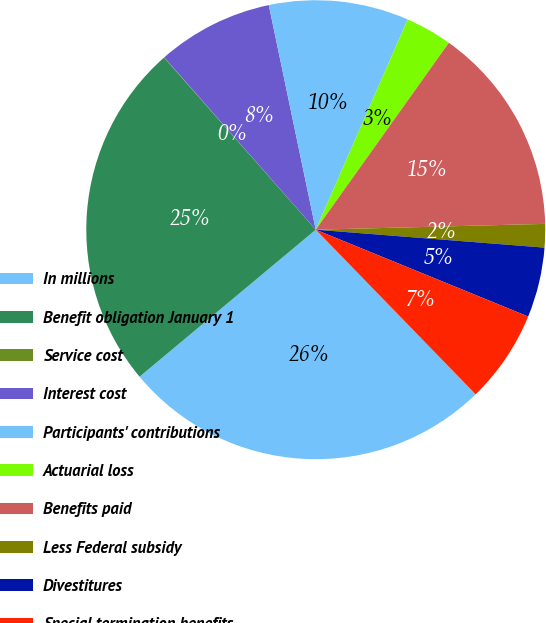Convert chart to OTSL. <chart><loc_0><loc_0><loc_500><loc_500><pie_chart><fcel>In millions<fcel>Benefit obligation January 1<fcel>Service cost<fcel>Interest cost<fcel>Participants' contributions<fcel>Actuarial loss<fcel>Benefits paid<fcel>Less Federal subsidy<fcel>Divestitures<fcel>Special termination benefits<nl><fcel>26.2%<fcel>24.57%<fcel>0.02%<fcel>8.2%<fcel>9.84%<fcel>3.29%<fcel>14.75%<fcel>1.65%<fcel>4.93%<fcel>6.56%<nl></chart> 